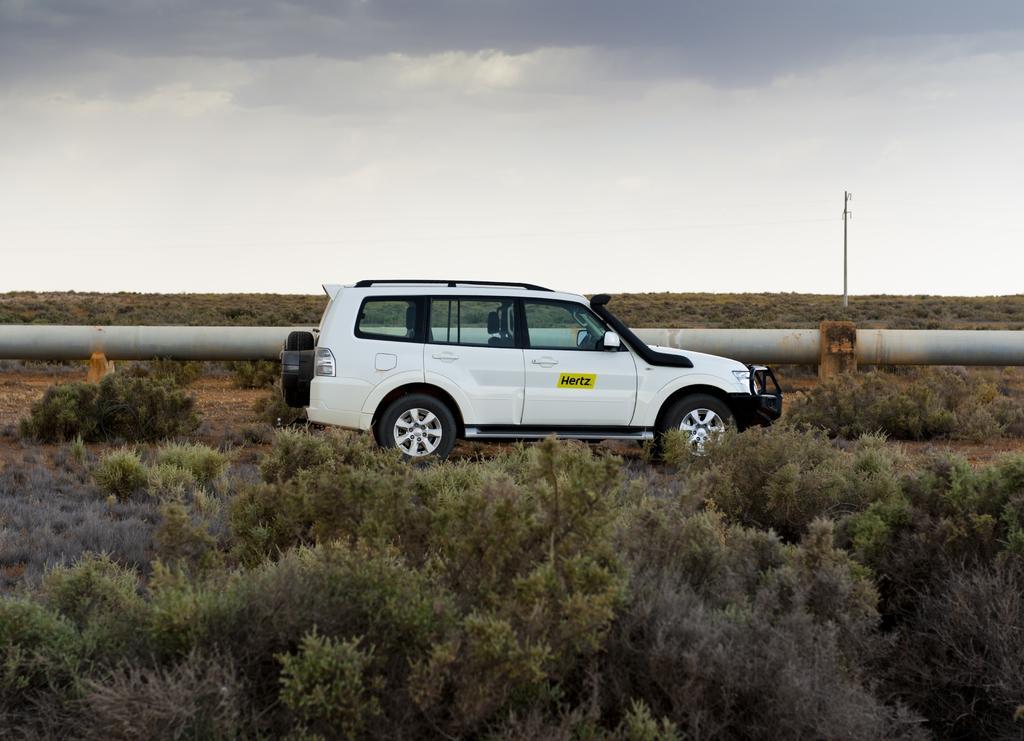Please provide a concise description of this image. In this image I can see there is a car. And there are trees and a pipeline. And at the top there is a sky. 